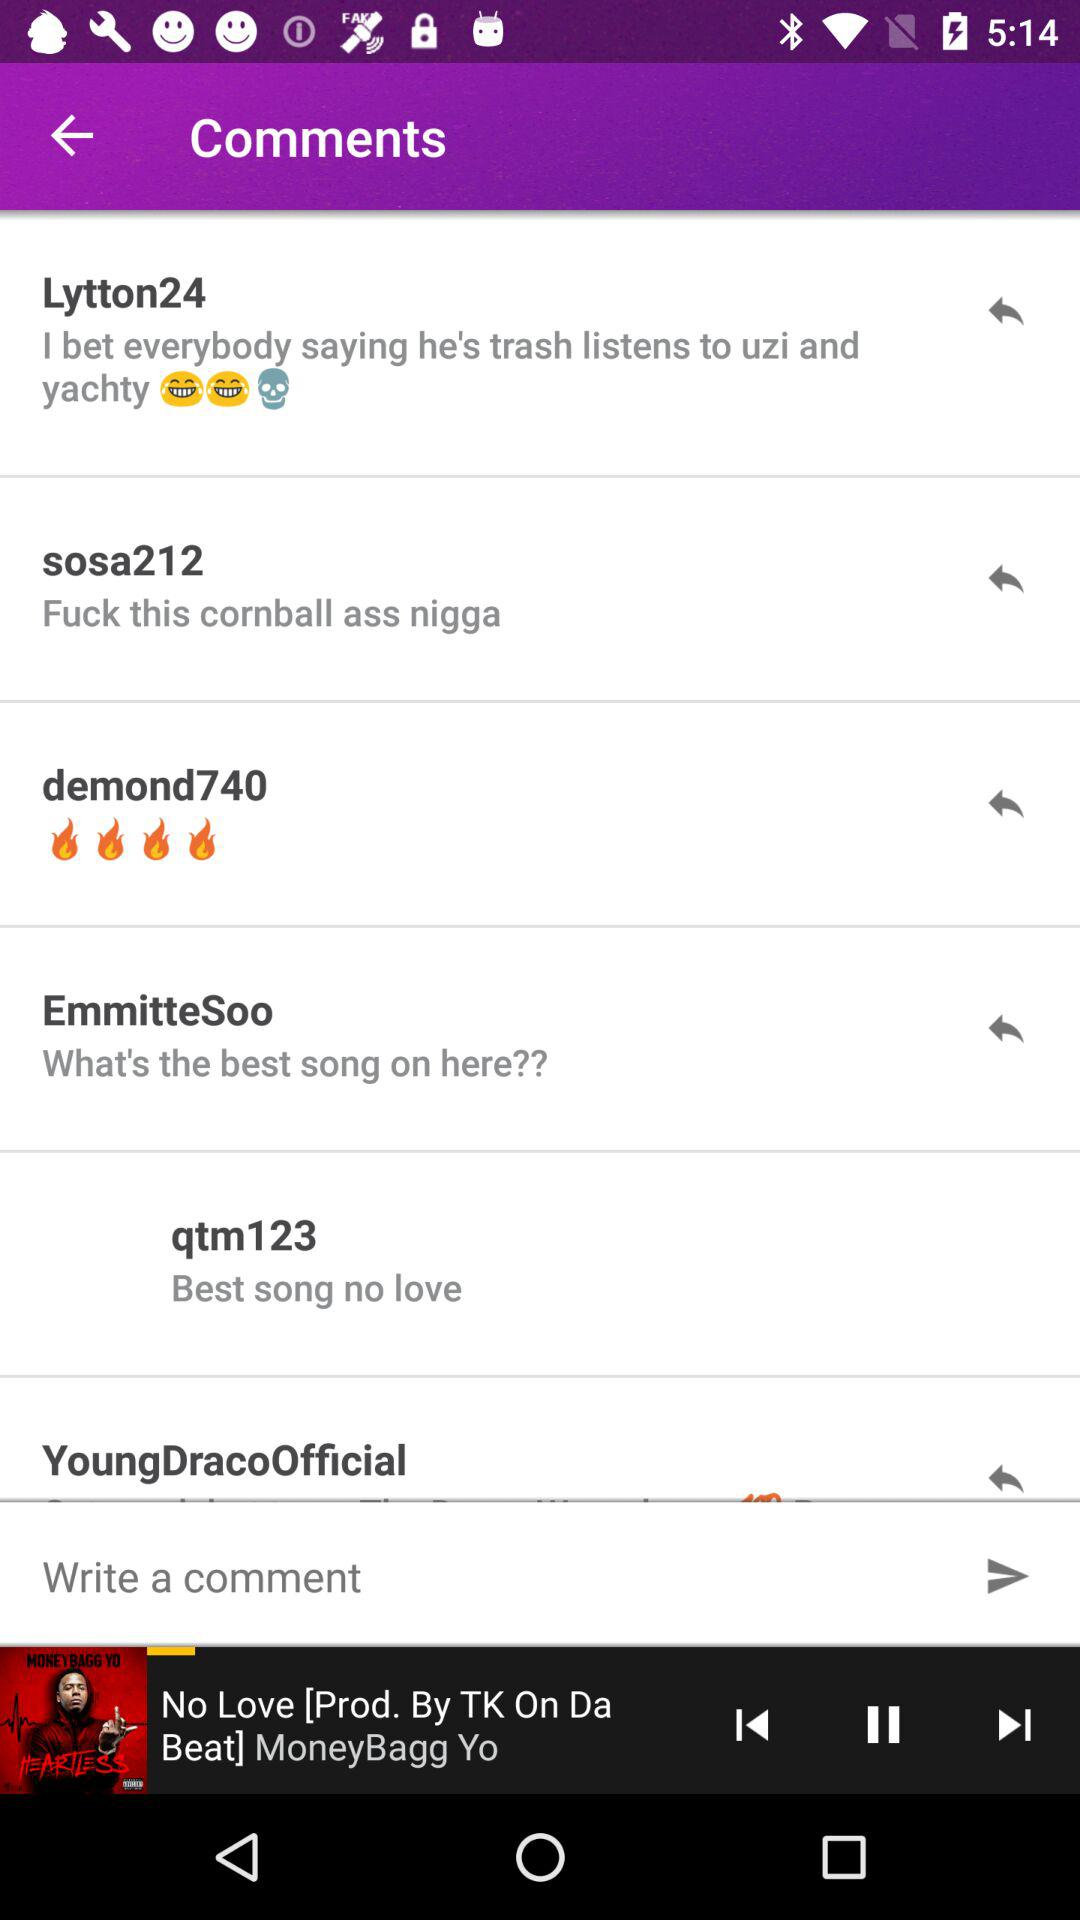Which user commented, "What's the best song on here??"? The user who commented, "What's the best song on here??" is "EmmitteSoo". 